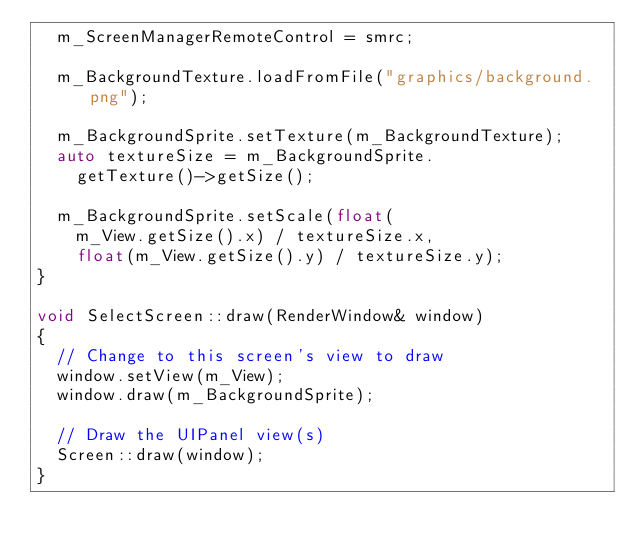<code> <loc_0><loc_0><loc_500><loc_500><_C++_>	m_ScreenManagerRemoteControl = smrc;

	m_BackgroundTexture.loadFromFile("graphics/background.png");

	m_BackgroundSprite.setTexture(m_BackgroundTexture);
	auto textureSize = m_BackgroundSprite.
		getTexture()->getSize();

	m_BackgroundSprite.setScale(float(
		m_View.getSize().x) / textureSize.x,
		float(m_View.getSize().y) / textureSize.y);
}

void SelectScreen::draw(RenderWindow& window)
{
	// Change to this screen's view to draw
	window.setView(m_View);
	window.draw(m_BackgroundSprite);

	// Draw the UIPanel view(s)
	Screen::draw(window);
}</code> 